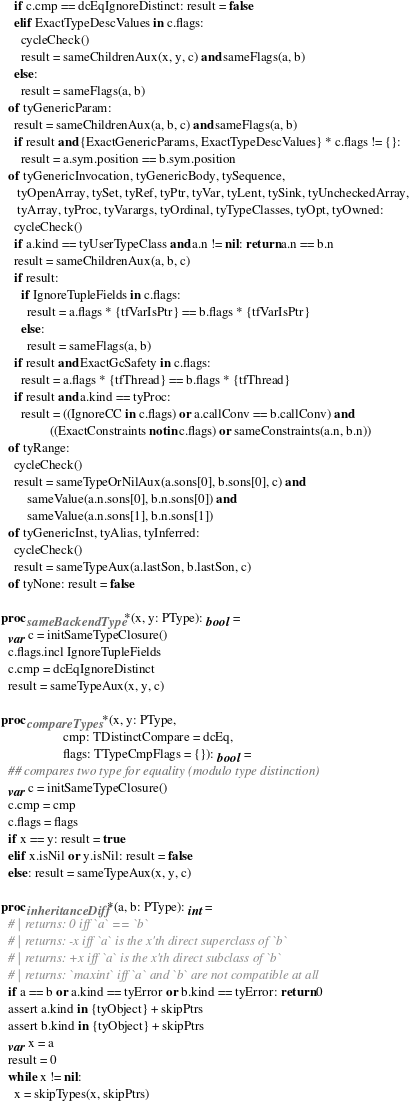Convert code to text. <code><loc_0><loc_0><loc_500><loc_500><_Nim_>    if c.cmp == dcEqIgnoreDistinct: result = false
    elif ExactTypeDescValues in c.flags:
      cycleCheck()
      result = sameChildrenAux(x, y, c) and sameFlags(a, b)
    else:
      result = sameFlags(a, b)
  of tyGenericParam:
    result = sameChildrenAux(a, b, c) and sameFlags(a, b)
    if result and {ExactGenericParams, ExactTypeDescValues} * c.flags != {}:
      result = a.sym.position == b.sym.position
  of tyGenericInvocation, tyGenericBody, tySequence,
     tyOpenArray, tySet, tyRef, tyPtr, tyVar, tyLent, tySink, tyUncheckedArray,
     tyArray, tyProc, tyVarargs, tyOrdinal, tyTypeClasses, tyOpt, tyOwned:
    cycleCheck()
    if a.kind == tyUserTypeClass and a.n != nil: return a.n == b.n
    result = sameChildrenAux(a, b, c)
    if result:
      if IgnoreTupleFields in c.flags:
        result = a.flags * {tfVarIsPtr} == b.flags * {tfVarIsPtr}
      else:
        result = sameFlags(a, b)
    if result and ExactGcSafety in c.flags:
      result = a.flags * {tfThread} == b.flags * {tfThread}
    if result and a.kind == tyProc:
      result = ((IgnoreCC in c.flags) or a.callConv == b.callConv) and
               ((ExactConstraints notin c.flags) or sameConstraints(a.n, b.n))
  of tyRange:
    cycleCheck()
    result = sameTypeOrNilAux(a.sons[0], b.sons[0], c) and
        sameValue(a.n.sons[0], b.n.sons[0]) and
        sameValue(a.n.sons[1], b.n.sons[1])
  of tyGenericInst, tyAlias, tyInferred:
    cycleCheck()
    result = sameTypeAux(a.lastSon, b.lastSon, c)
  of tyNone: result = false

proc sameBackendType*(x, y: PType): bool =
  var c = initSameTypeClosure()
  c.flags.incl IgnoreTupleFields
  c.cmp = dcEqIgnoreDistinct
  result = sameTypeAux(x, y, c)

proc compareTypes*(x, y: PType,
                   cmp: TDistinctCompare = dcEq,
                   flags: TTypeCmpFlags = {}): bool =
  ## compares two type for equality (modulo type distinction)
  var c = initSameTypeClosure()
  c.cmp = cmp
  c.flags = flags
  if x == y: result = true
  elif x.isNil or y.isNil: result = false
  else: result = sameTypeAux(x, y, c)

proc inheritanceDiff*(a, b: PType): int =
  # | returns: 0 iff `a` == `b`
  # | returns: -x iff `a` is the x'th direct superclass of `b`
  # | returns: +x iff `a` is the x'th direct subclass of `b`
  # | returns: `maxint` iff `a` and `b` are not compatible at all
  if a == b or a.kind == tyError or b.kind == tyError: return 0
  assert a.kind in {tyObject} + skipPtrs
  assert b.kind in {tyObject} + skipPtrs
  var x = a
  result = 0
  while x != nil:
    x = skipTypes(x, skipPtrs)</code> 